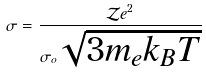Convert formula to latex. <formula><loc_0><loc_0><loc_500><loc_500>\sigma = \frac { { \mathcal { Z } } e ^ { 2 } } { \sigma _ { o } \sqrt { 3 m _ { e } k _ { B } T } }</formula> 